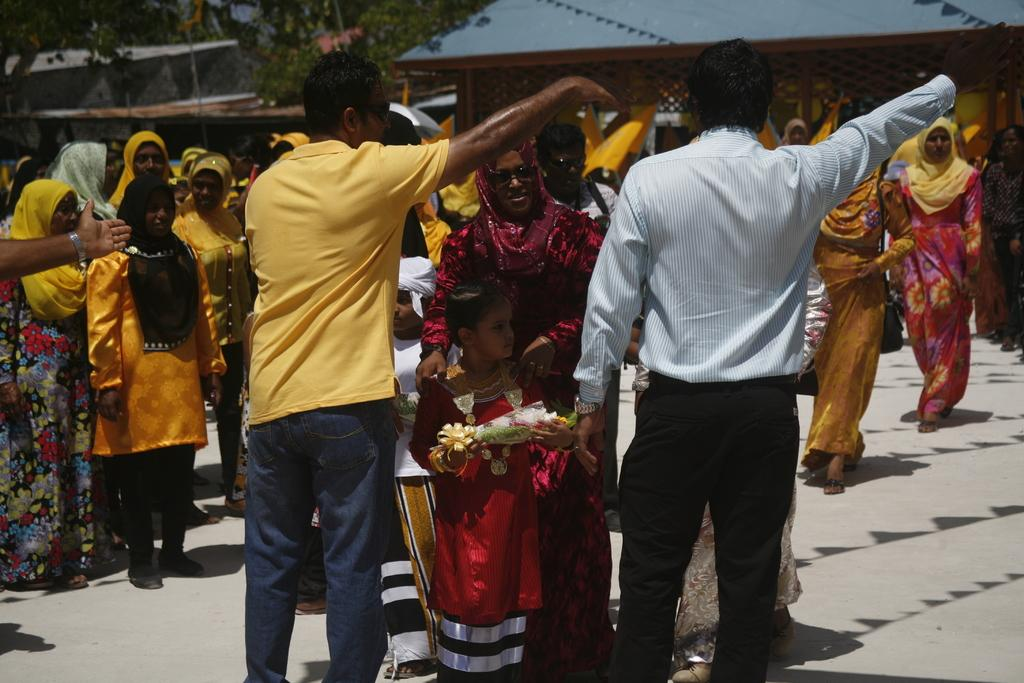What is happening in the image? There are people standing in the image. Can you describe the clothing of the people? The people are wearing different color dresses. What is one person holding in the image? One person is holding something. What can be seen in the background of the image? There are trees and sheds visible in the background. What type of protest is taking place in the image? There is no protest present in the image; it simply shows people standing and wearing different color dresses. 